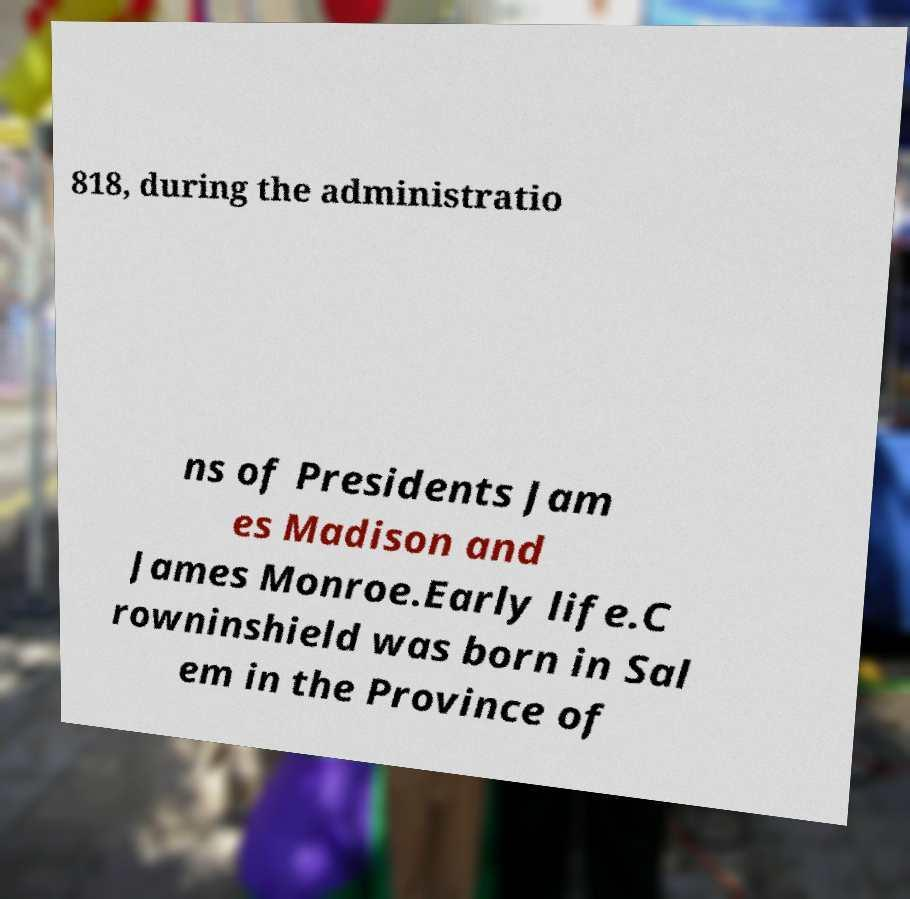Please identify and transcribe the text found in this image. 818, during the administratio ns of Presidents Jam es Madison and James Monroe.Early life.C rowninshield was born in Sal em in the Province of 